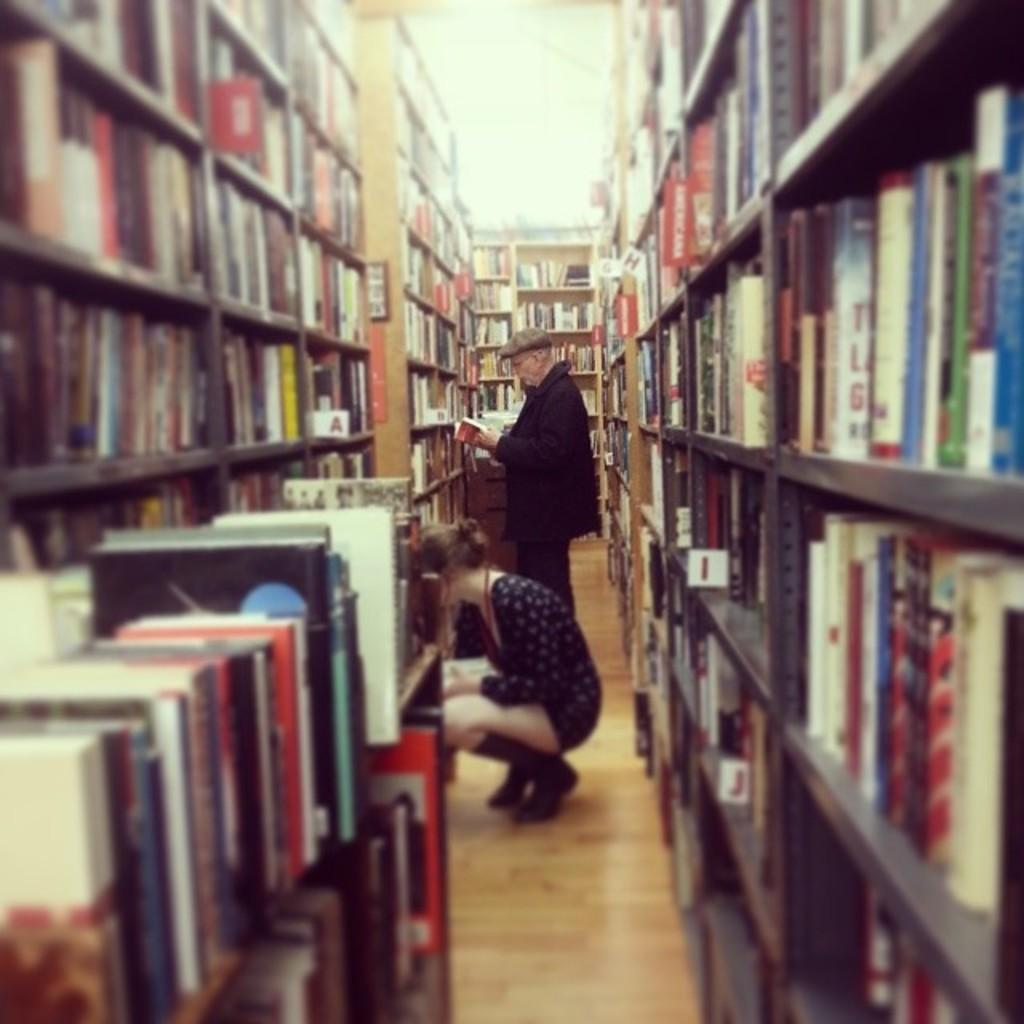What is the main subject of the image? There is a beautiful woman in the image. What is the woman doing in the image? The woman is searching for books. Who else is present in the image? There is an old man in the image. What is the old man doing in the image? The old man is reading a book. What can be seen on the old man's head? The old man is wearing a cap. What can be seen in the background of the image? There are books in the racks in the image. What type of bread can be seen in the image? There is no bread present in the image. What kind of toys can be seen in the image? There are no toys present in the image. 